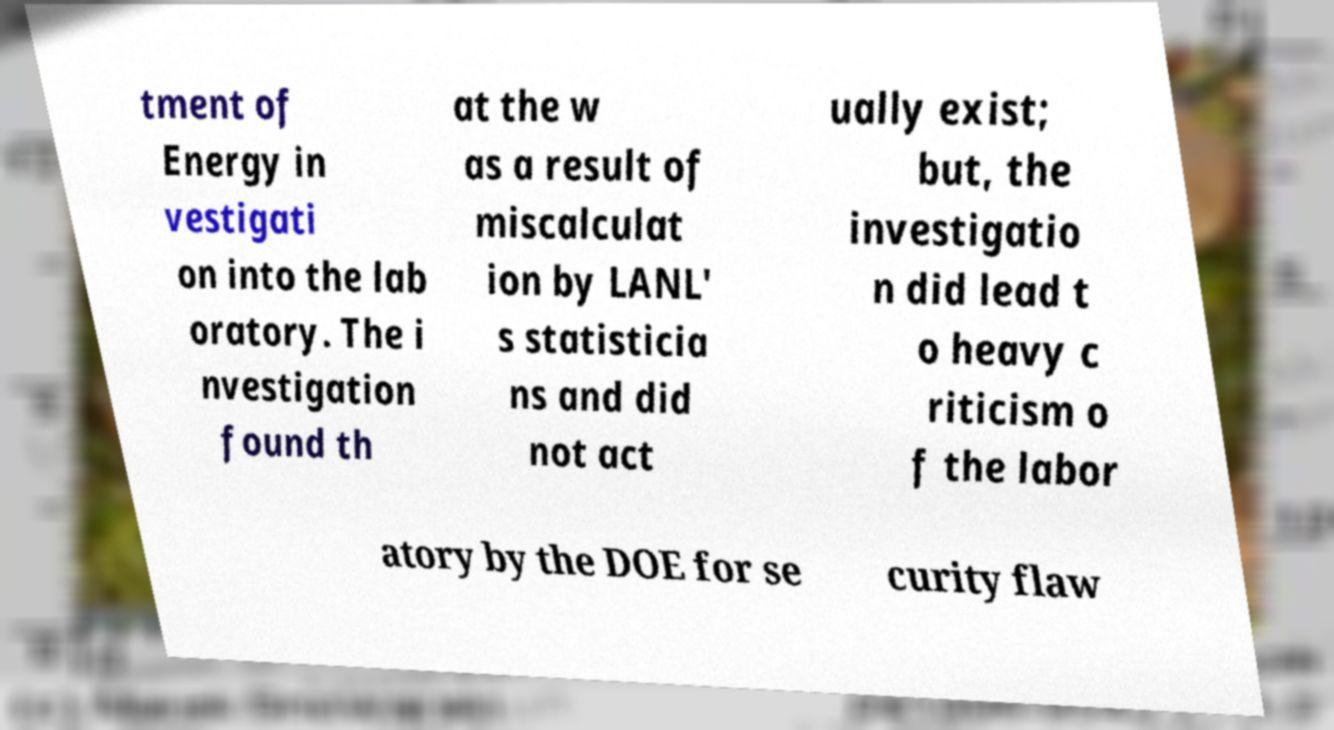I need the written content from this picture converted into text. Can you do that? tment of Energy in vestigati on into the lab oratory. The i nvestigation found th at the w as a result of miscalculat ion by LANL' s statisticia ns and did not act ually exist; but, the investigatio n did lead t o heavy c riticism o f the labor atory by the DOE for se curity flaw 